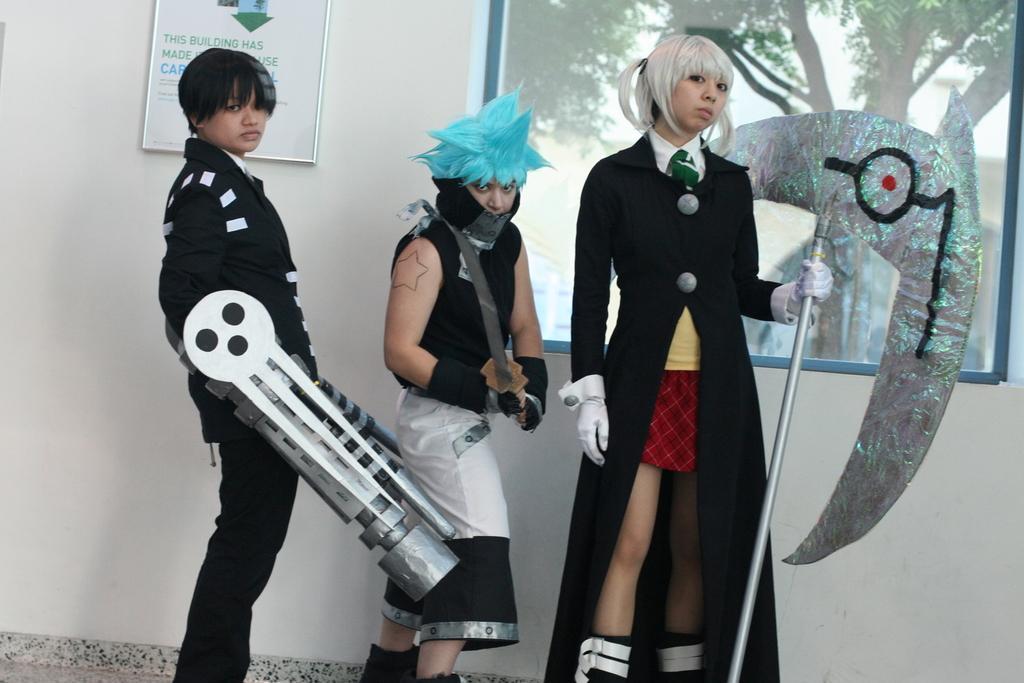In one or two sentences, can you explain what this image depicts? In the center of the picture there are three persons in different costumes. On the right the person is holding an axe like object. In the background there are window, board and wall, through the window we can see tree. 